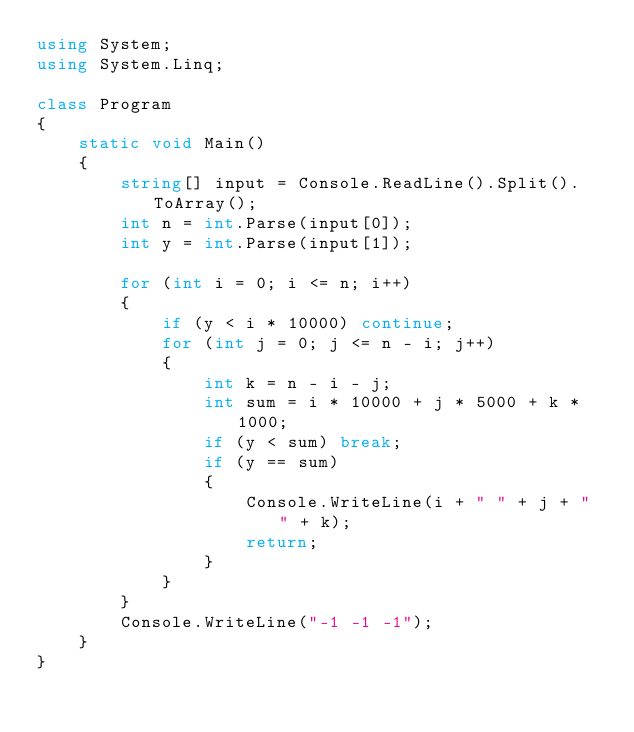Convert code to text. <code><loc_0><loc_0><loc_500><loc_500><_C#_>using System;
using System.Linq;

class Program
{
    static void Main()
    {
        string[] input = Console.ReadLine().Split().ToArray();
        int n = int.Parse(input[0]);
        int y = int.Parse(input[1]);

        for (int i = 0; i <= n; i++)
        {
            if (y < i * 10000) continue;
            for (int j = 0; j <= n - i; j++)
            {
                int k = n - i - j;
                int sum = i * 10000 + j * 5000 + k * 1000;
                if (y < sum) break;
                if (y == sum)
                {
                    Console.WriteLine(i + " " + j + " " + k);
                    return;
                }
            }
        }
        Console.WriteLine("-1 -1 -1");
    }
}</code> 